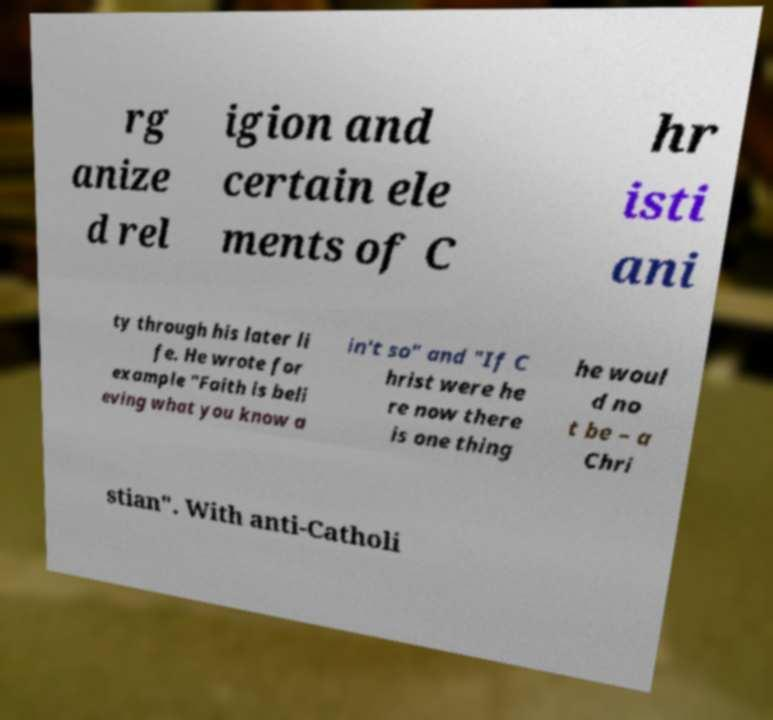For documentation purposes, I need the text within this image transcribed. Could you provide that? rg anize d rel igion and certain ele ments of C hr isti ani ty through his later li fe. He wrote for example "Faith is beli eving what you know a in't so" and "If C hrist were he re now there is one thing he woul d no t be – a Chri stian". With anti-Catholi 